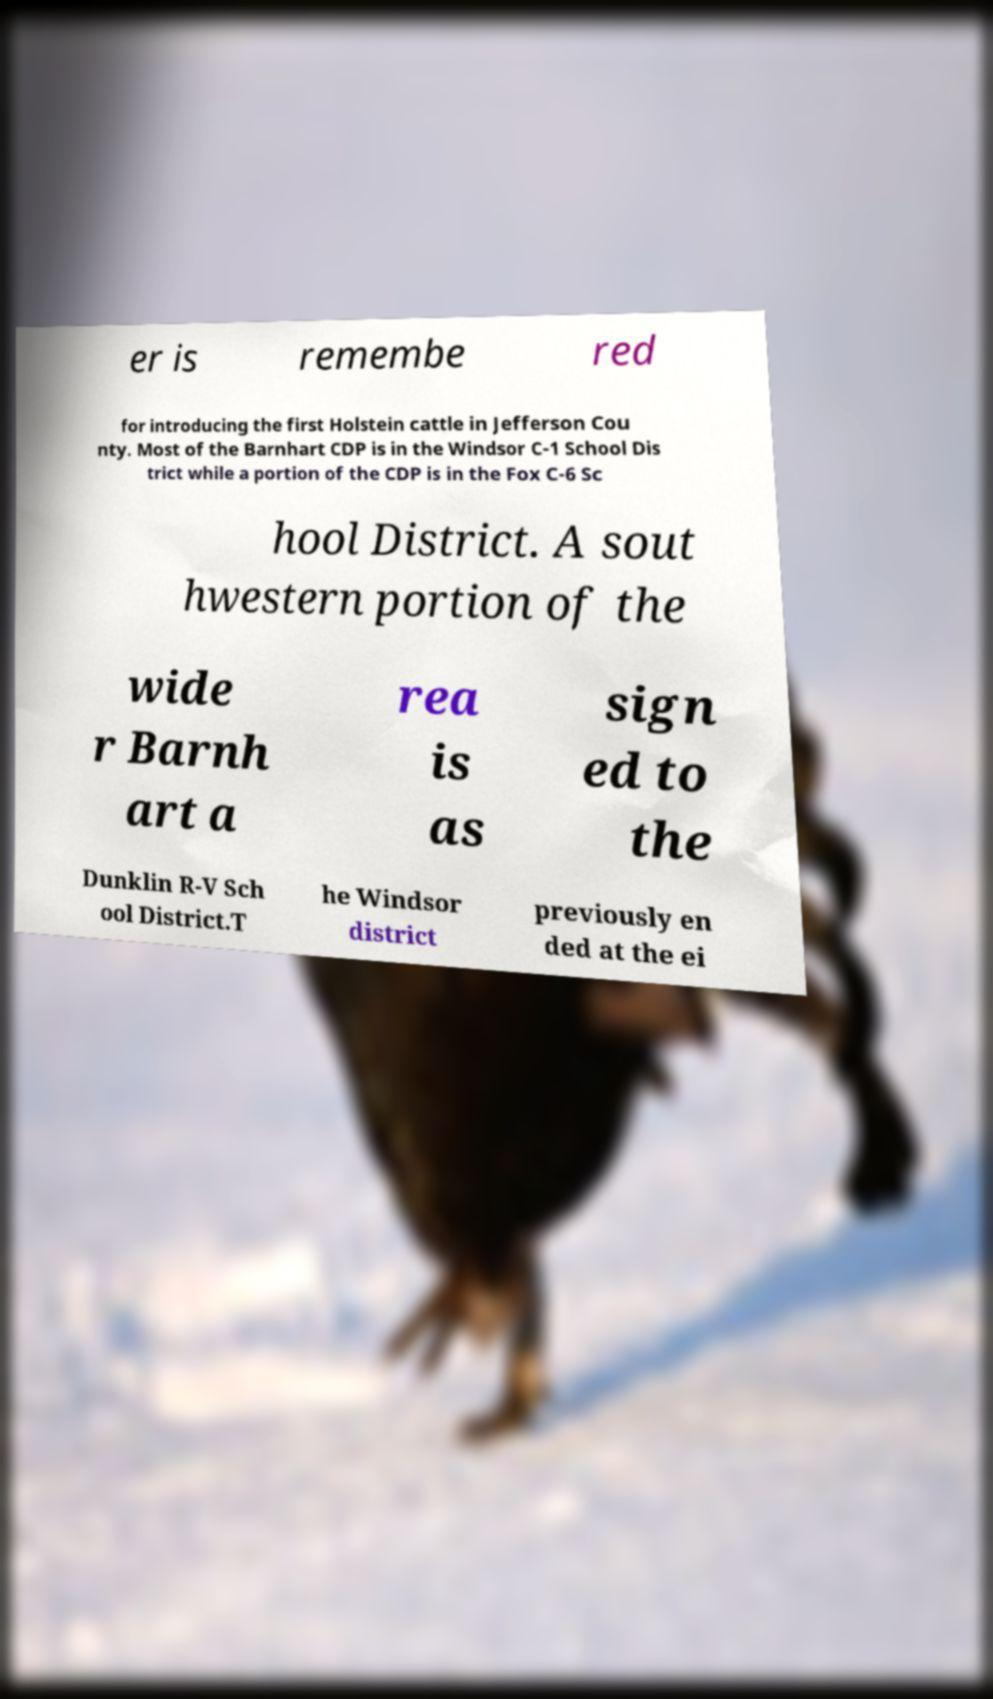Please read and relay the text visible in this image. What does it say? er is remembe red for introducing the first Holstein cattle in Jefferson Cou nty. Most of the Barnhart CDP is in the Windsor C-1 School Dis trict while a portion of the CDP is in the Fox C-6 Sc hool District. A sout hwestern portion of the wide r Barnh art a rea is as sign ed to the Dunklin R-V Sch ool District.T he Windsor district previously en ded at the ei 